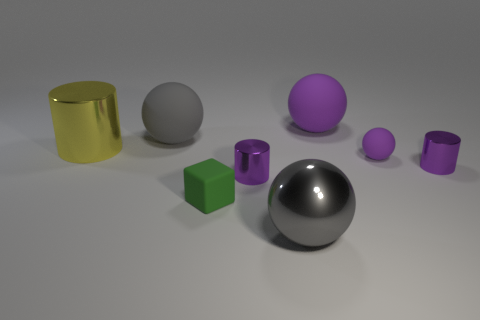Is the size of the gray rubber ball the same as the purple thing that is behind the yellow object?
Provide a short and direct response. Yes. What number of purple metallic things have the same size as the yellow metallic cylinder?
Offer a terse response. 0. There is a tiny sphere that is made of the same material as the tiny green object; what color is it?
Make the answer very short. Purple. Is the number of big matte cylinders greater than the number of small matte blocks?
Provide a succinct answer. No. Is the material of the cube the same as the big yellow cylinder?
Ensure brevity in your answer.  No. What shape is the other small thing that is made of the same material as the green object?
Ensure brevity in your answer.  Sphere. Is the number of big purple objects less than the number of rubber things?
Your answer should be compact. Yes. What is the material of the ball that is in front of the big metallic cylinder and behind the green rubber block?
Ensure brevity in your answer.  Rubber. There is a yellow metallic object that is on the left side of the tiny purple ball that is in front of the purple sphere that is behind the large cylinder; how big is it?
Provide a short and direct response. Large. There is a tiny purple rubber object; does it have the same shape as the big gray object right of the green rubber object?
Offer a terse response. Yes. 